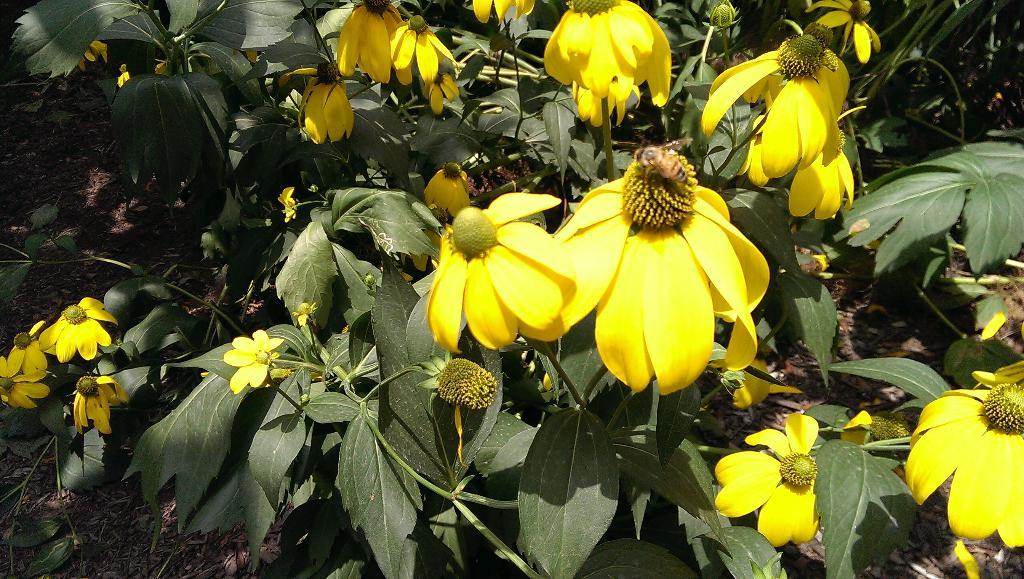What type of living organisms can be seen in the image? Plants are visible in the image. What color are the flowers on the plants? The flowers on the plants are yellow. What other living organism can be seen in the image? There is an insect in the image. What is the surface on which the plants are growing? The ground is visible in the image. Are there any giants visible in the image? No, there are no giants present in the image. What type of pocket can be seen in the image? There is no pocket visible in the image. 